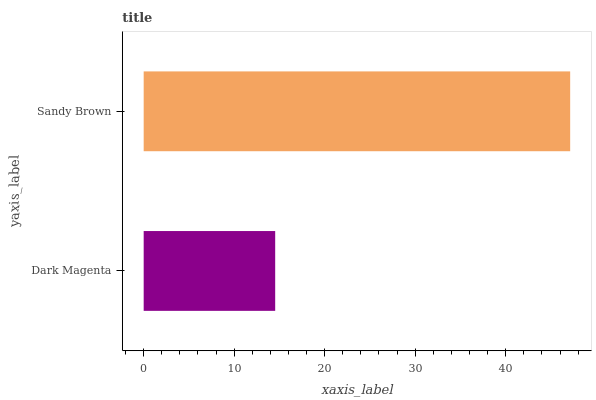Is Dark Magenta the minimum?
Answer yes or no. Yes. Is Sandy Brown the maximum?
Answer yes or no. Yes. Is Sandy Brown the minimum?
Answer yes or no. No. Is Sandy Brown greater than Dark Magenta?
Answer yes or no. Yes. Is Dark Magenta less than Sandy Brown?
Answer yes or no. Yes. Is Dark Magenta greater than Sandy Brown?
Answer yes or no. No. Is Sandy Brown less than Dark Magenta?
Answer yes or no. No. Is Sandy Brown the high median?
Answer yes or no. Yes. Is Dark Magenta the low median?
Answer yes or no. Yes. Is Dark Magenta the high median?
Answer yes or no. No. Is Sandy Brown the low median?
Answer yes or no. No. 